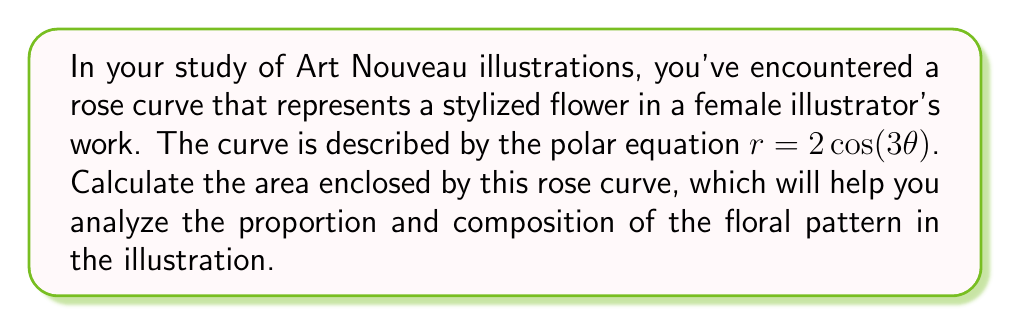Can you answer this question? To calculate the area enclosed by a rose curve, we can use the formula for the area of a polar curve:

$$A = \frac{1}{2} \int_{0}^{2\pi} r^2 d\theta$$

For our rose curve $r = 2\cos(3\theta)$, we need to follow these steps:

1) Square the radius function:
   $r^2 = (2\cos(3\theta))^2 = 4\cos^2(3\theta)$

2) Substitute this into the integral:
   $$A = \frac{1}{2} \int_{0}^{2\pi} 4\cos^2(3\theta) d\theta$$

3) Use the trigonometric identity $\cos^2(x) = \frac{1}{2}(1 + \cos(2x))$:
   $$A = \frac{1}{2} \int_{0}^{2\pi} 4 \cdot \frac{1}{2}(1 + \cos(6\theta)) d\theta$$
   $$A = \int_{0}^{2\pi} (1 + \cos(6\theta)) d\theta$$

4) Integrate:
   $$A = [\theta + \frac{1}{6}\sin(6\theta)]_{0}^{2\pi}$$

5) Evaluate the integral:
   $$A = (2\pi + \frac{1}{6}\sin(12\pi)) - (0 + \frac{1}{6}\sin(0))$$
   $$A = 2\pi + 0 - 0 = 2\pi$$

Therefore, the area enclosed by the rose curve is $2\pi$ square units.
Answer: $2\pi$ square units 